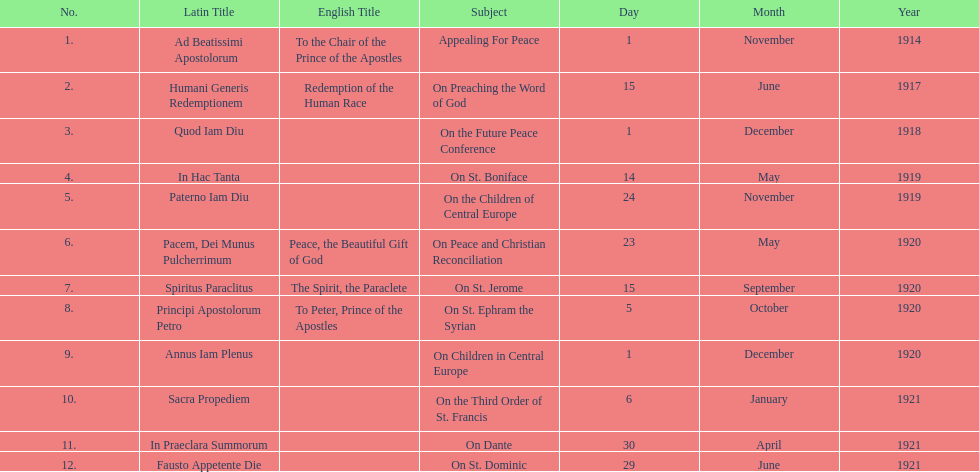What is the only subject on 23 may 1920? On Peace and Christian Reconciliation. 